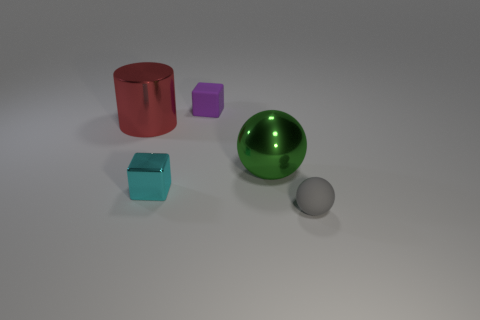Add 1 large cyan cubes. How many objects exist? 6 Subtract all balls. How many objects are left? 3 Subtract all yellow metal things. Subtract all gray things. How many objects are left? 4 Add 2 large metal things. How many large metal things are left? 4 Add 5 large brown balls. How many large brown balls exist? 5 Subtract 1 purple cubes. How many objects are left? 4 